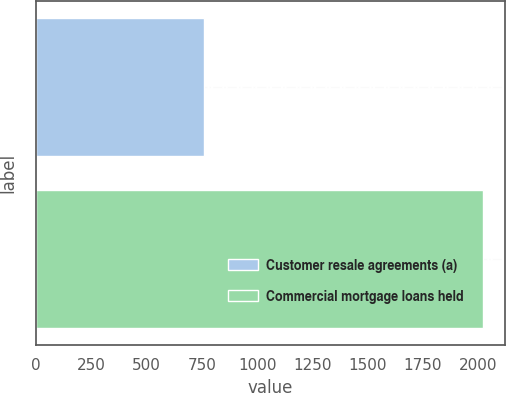Convert chart. <chart><loc_0><loc_0><loc_500><loc_500><bar_chart><fcel>Customer resale agreements (a)<fcel>Commercial mortgage loans held<nl><fcel>761<fcel>2020<nl></chart> 